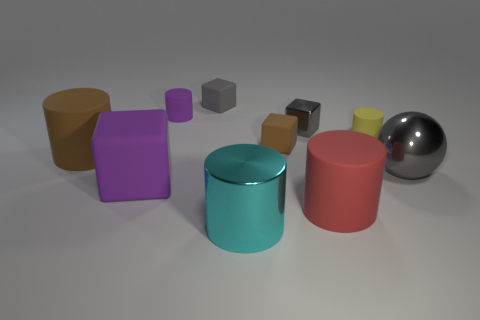Subtract all big blocks. How many blocks are left? 3 Subtract all brown cylinders. How many cylinders are left? 4 Subtract 2 cubes. How many cubes are left? 2 Subtract all big purple metal cylinders. Subtract all metal cylinders. How many objects are left? 9 Add 1 matte objects. How many matte objects are left? 8 Add 2 big gray metallic spheres. How many big gray metallic spheres exist? 3 Subtract 0 green spheres. How many objects are left? 10 Subtract all cubes. How many objects are left? 6 Subtract all green cylinders. Subtract all gray spheres. How many cylinders are left? 5 Subtract all brown balls. How many green cylinders are left? 0 